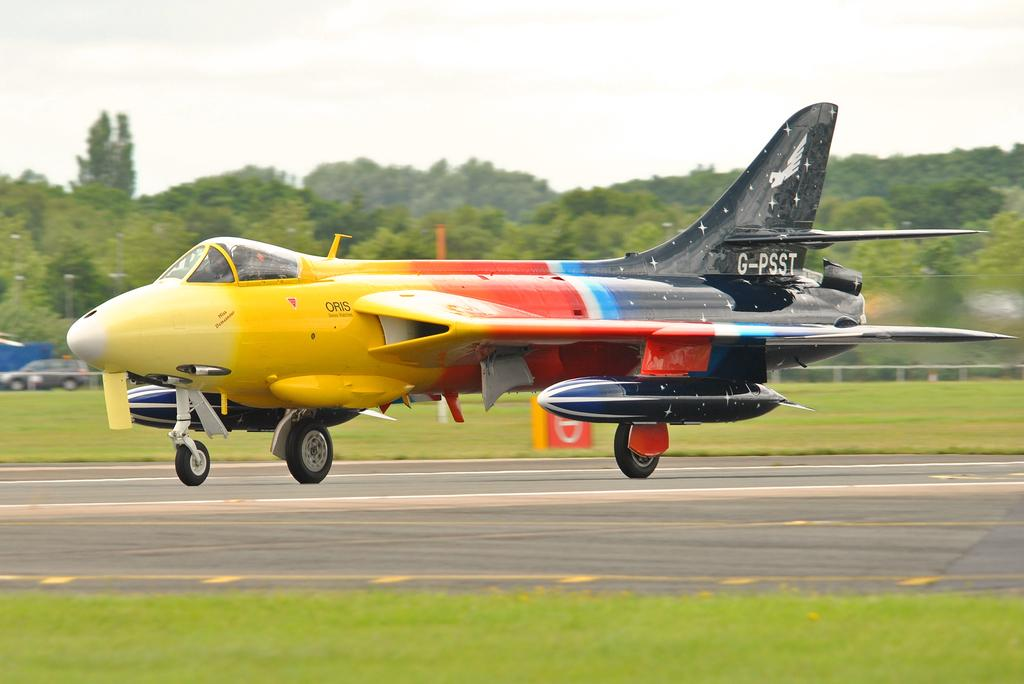<image>
Describe the image concisely. An airplane that is yellow, red blue and black in color on the runway with the G-PSST on the back wing of the plane. 